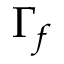Convert formula to latex. <formula><loc_0><loc_0><loc_500><loc_500>\Gamma _ { f }</formula> 